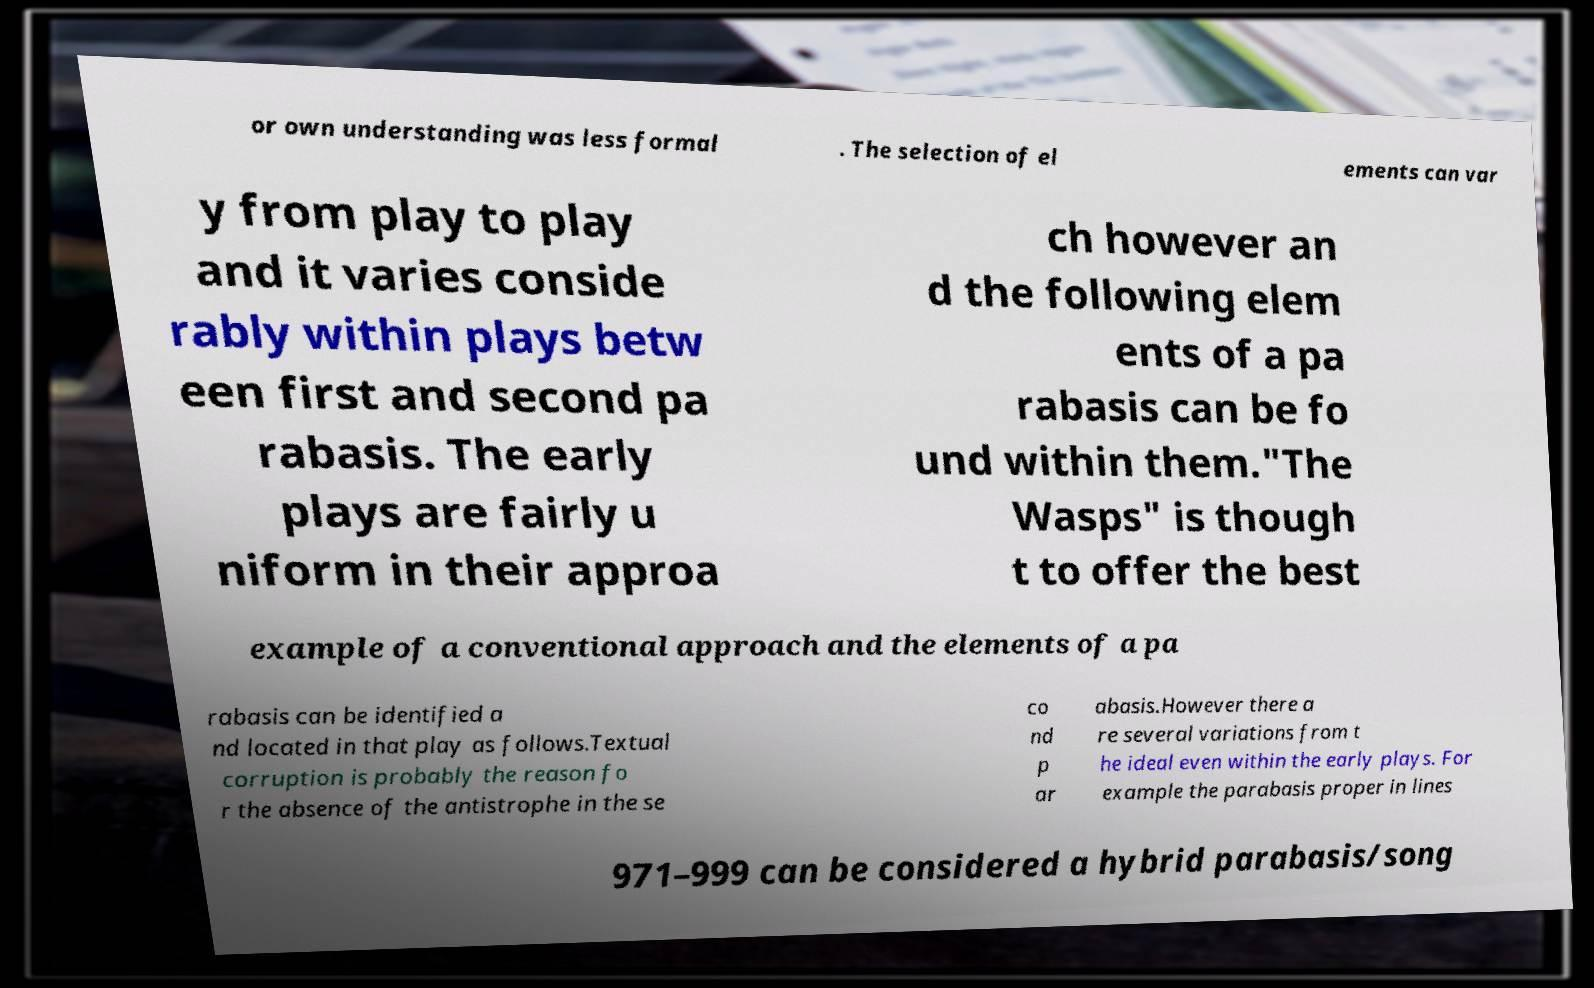Could you extract and type out the text from this image? or own understanding was less formal . The selection of el ements can var y from play to play and it varies conside rably within plays betw een first and second pa rabasis. The early plays are fairly u niform in their approa ch however an d the following elem ents of a pa rabasis can be fo und within them."The Wasps" is though t to offer the best example of a conventional approach and the elements of a pa rabasis can be identified a nd located in that play as follows.Textual corruption is probably the reason fo r the absence of the antistrophe in the se co nd p ar abasis.However there a re several variations from t he ideal even within the early plays. For example the parabasis proper in lines 971–999 can be considered a hybrid parabasis/song 